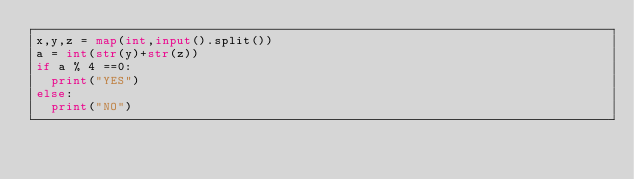Convert code to text. <code><loc_0><loc_0><loc_500><loc_500><_Python_>x,y,z = map(int,input().split())
a = int(str(y)+str(z))
if a % 4 ==0:
  print("YES")
else:
  print("NO")</code> 